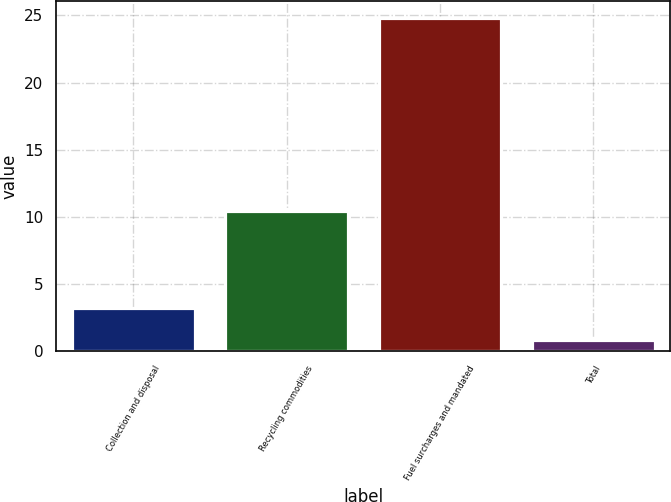Convert chart. <chart><loc_0><loc_0><loc_500><loc_500><bar_chart><fcel>Collection and disposal<fcel>Recycling commodities<fcel>Fuel surcharges and mandated<fcel>Total<nl><fcel>3.2<fcel>10.4<fcel>24.8<fcel>0.8<nl></chart> 